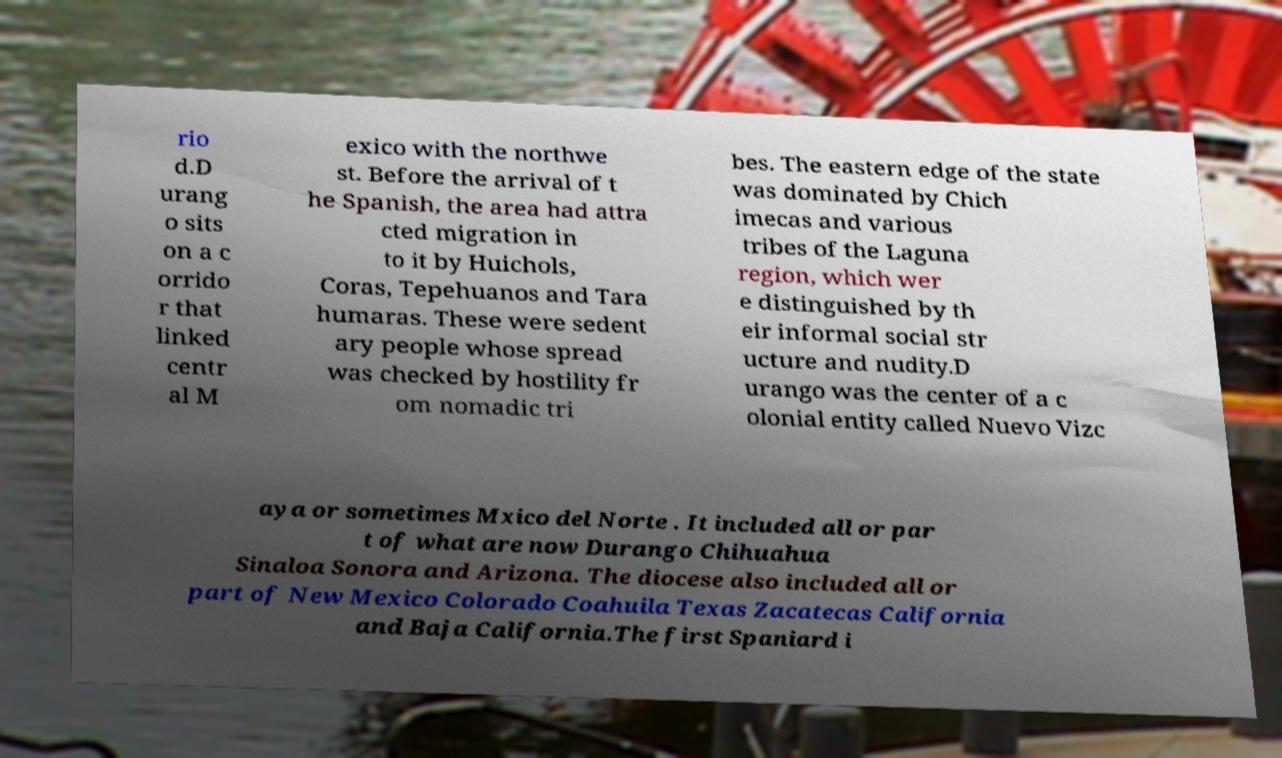There's text embedded in this image that I need extracted. Can you transcribe it verbatim? rio d.D urang o sits on a c orrido r that linked centr al M exico with the northwe st. Before the arrival of t he Spanish, the area had attra cted migration in to it by Huichols, Coras, Tepehuanos and Tara humaras. These were sedent ary people whose spread was checked by hostility fr om nomadic tri bes. The eastern edge of the state was dominated by Chich imecas and various tribes of the Laguna region, which wer e distinguished by th eir informal social str ucture and nudity.D urango was the center of a c olonial entity called Nuevo Vizc aya or sometimes Mxico del Norte . It included all or par t of what are now Durango Chihuahua Sinaloa Sonora and Arizona. The diocese also included all or part of New Mexico Colorado Coahuila Texas Zacatecas California and Baja California.The first Spaniard i 